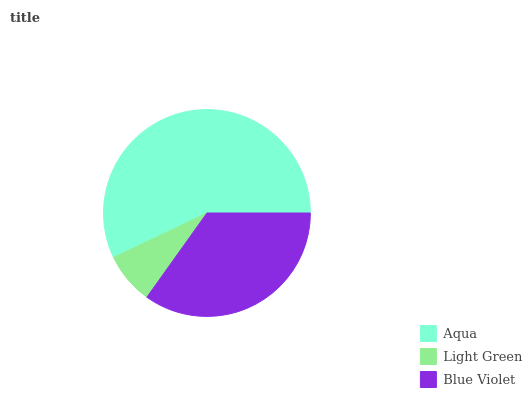Is Light Green the minimum?
Answer yes or no. Yes. Is Aqua the maximum?
Answer yes or no. Yes. Is Blue Violet the minimum?
Answer yes or no. No. Is Blue Violet the maximum?
Answer yes or no. No. Is Blue Violet greater than Light Green?
Answer yes or no. Yes. Is Light Green less than Blue Violet?
Answer yes or no. Yes. Is Light Green greater than Blue Violet?
Answer yes or no. No. Is Blue Violet less than Light Green?
Answer yes or no. No. Is Blue Violet the high median?
Answer yes or no. Yes. Is Blue Violet the low median?
Answer yes or no. Yes. Is Light Green the high median?
Answer yes or no. No. Is Light Green the low median?
Answer yes or no. No. 